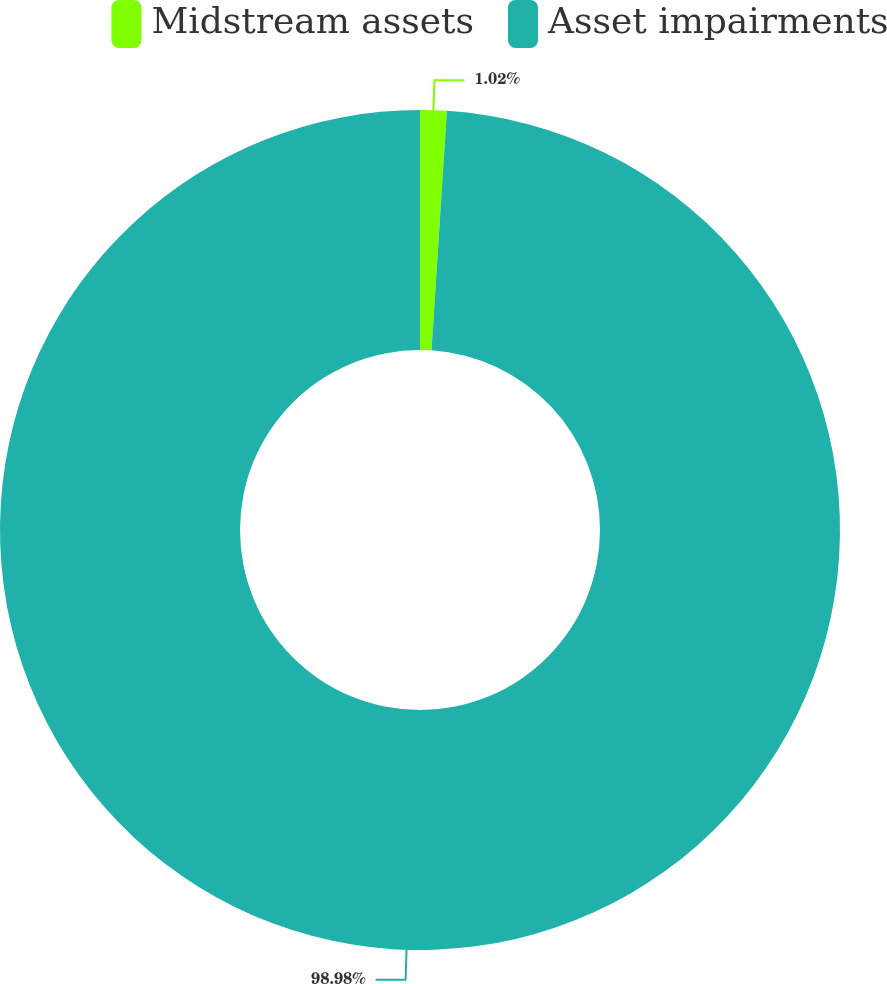Convert chart to OTSL. <chart><loc_0><loc_0><loc_500><loc_500><pie_chart><fcel>Midstream assets<fcel>Asset impairments<nl><fcel>1.02%<fcel>98.98%<nl></chart> 